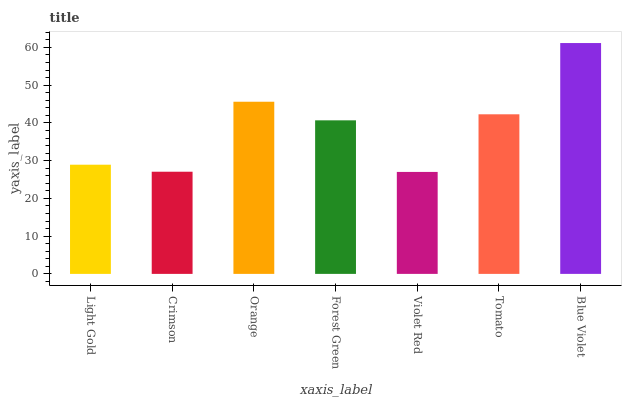Is Violet Red the minimum?
Answer yes or no. Yes. Is Blue Violet the maximum?
Answer yes or no. Yes. Is Crimson the minimum?
Answer yes or no. No. Is Crimson the maximum?
Answer yes or no. No. Is Light Gold greater than Crimson?
Answer yes or no. Yes. Is Crimson less than Light Gold?
Answer yes or no. Yes. Is Crimson greater than Light Gold?
Answer yes or no. No. Is Light Gold less than Crimson?
Answer yes or no. No. Is Forest Green the high median?
Answer yes or no. Yes. Is Forest Green the low median?
Answer yes or no. Yes. Is Crimson the high median?
Answer yes or no. No. Is Violet Red the low median?
Answer yes or no. No. 